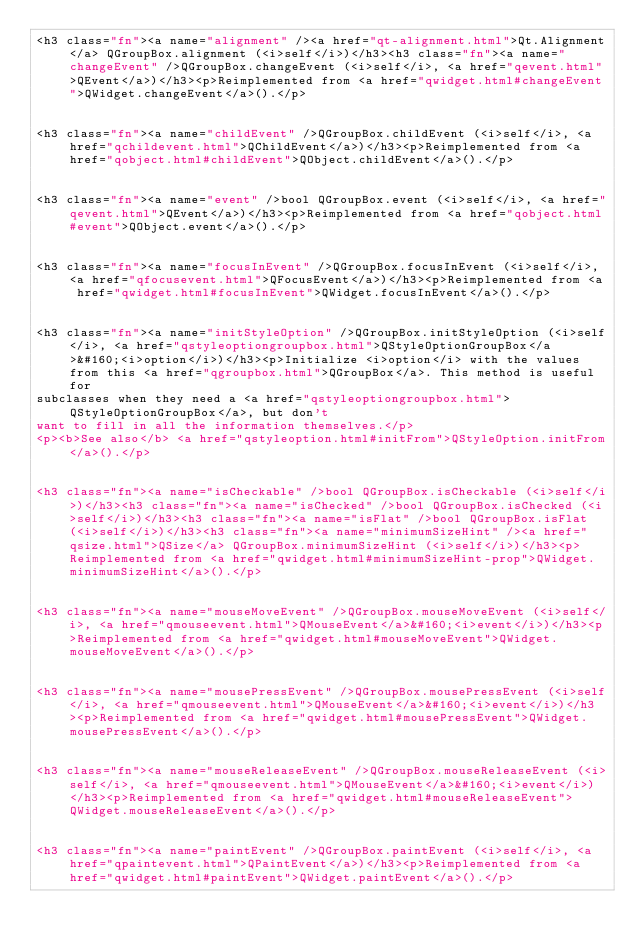Convert code to text. <code><loc_0><loc_0><loc_500><loc_500><_HTML_><h3 class="fn"><a name="alignment" /><a href="qt-alignment.html">Qt.Alignment</a> QGroupBox.alignment (<i>self</i>)</h3><h3 class="fn"><a name="changeEvent" />QGroupBox.changeEvent (<i>self</i>, <a href="qevent.html">QEvent</a>)</h3><p>Reimplemented from <a href="qwidget.html#changeEvent">QWidget.changeEvent</a>().</p>


<h3 class="fn"><a name="childEvent" />QGroupBox.childEvent (<i>self</i>, <a href="qchildevent.html">QChildEvent</a>)</h3><p>Reimplemented from <a href="qobject.html#childEvent">QObject.childEvent</a>().</p>


<h3 class="fn"><a name="event" />bool QGroupBox.event (<i>self</i>, <a href="qevent.html">QEvent</a>)</h3><p>Reimplemented from <a href="qobject.html#event">QObject.event</a>().</p>


<h3 class="fn"><a name="focusInEvent" />QGroupBox.focusInEvent (<i>self</i>, <a href="qfocusevent.html">QFocusEvent</a>)</h3><p>Reimplemented from <a href="qwidget.html#focusInEvent">QWidget.focusInEvent</a>().</p>


<h3 class="fn"><a name="initStyleOption" />QGroupBox.initStyleOption (<i>self</i>, <a href="qstyleoptiongroupbox.html">QStyleOptionGroupBox</a>&#160;<i>option</i>)</h3><p>Initialize <i>option</i> with the values from this <a href="qgroupbox.html">QGroupBox</a>. This method is useful for
subclasses when they need a <a href="qstyleoptiongroupbox.html">QStyleOptionGroupBox</a>, but don't
want to fill in all the information themselves.</p>
<p><b>See also</b> <a href="qstyleoption.html#initFrom">QStyleOption.initFrom</a>().</p>


<h3 class="fn"><a name="isCheckable" />bool QGroupBox.isCheckable (<i>self</i>)</h3><h3 class="fn"><a name="isChecked" />bool QGroupBox.isChecked (<i>self</i>)</h3><h3 class="fn"><a name="isFlat" />bool QGroupBox.isFlat (<i>self</i>)</h3><h3 class="fn"><a name="minimumSizeHint" /><a href="qsize.html">QSize</a> QGroupBox.minimumSizeHint (<i>self</i>)</h3><p>Reimplemented from <a href="qwidget.html#minimumSizeHint-prop">QWidget.minimumSizeHint</a>().</p>


<h3 class="fn"><a name="mouseMoveEvent" />QGroupBox.mouseMoveEvent (<i>self</i>, <a href="qmouseevent.html">QMouseEvent</a>&#160;<i>event</i>)</h3><p>Reimplemented from <a href="qwidget.html#mouseMoveEvent">QWidget.mouseMoveEvent</a>().</p>


<h3 class="fn"><a name="mousePressEvent" />QGroupBox.mousePressEvent (<i>self</i>, <a href="qmouseevent.html">QMouseEvent</a>&#160;<i>event</i>)</h3><p>Reimplemented from <a href="qwidget.html#mousePressEvent">QWidget.mousePressEvent</a>().</p>


<h3 class="fn"><a name="mouseReleaseEvent" />QGroupBox.mouseReleaseEvent (<i>self</i>, <a href="qmouseevent.html">QMouseEvent</a>&#160;<i>event</i>)</h3><p>Reimplemented from <a href="qwidget.html#mouseReleaseEvent">QWidget.mouseReleaseEvent</a>().</p>


<h3 class="fn"><a name="paintEvent" />QGroupBox.paintEvent (<i>self</i>, <a href="qpaintevent.html">QPaintEvent</a>)</h3><p>Reimplemented from <a href="qwidget.html#paintEvent">QWidget.paintEvent</a>().</p>

</code> 